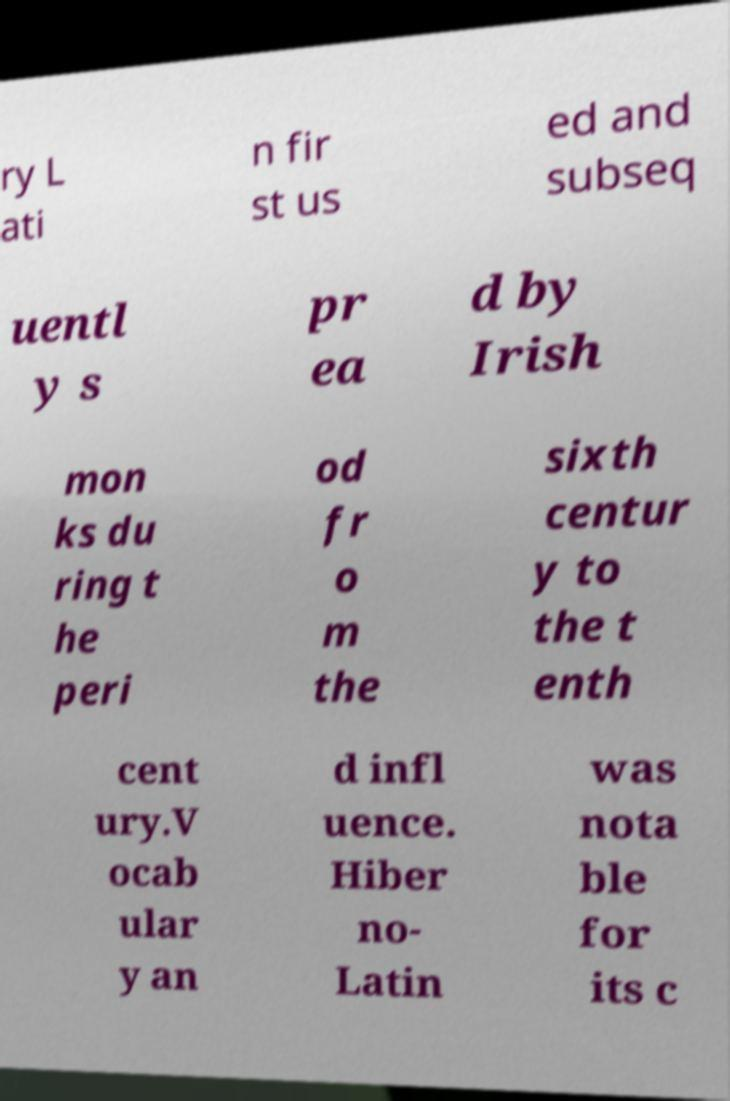What messages or text are displayed in this image? I need them in a readable, typed format. ry L ati n fir st us ed and subseq uentl y s pr ea d by Irish mon ks du ring t he peri od fr o m the sixth centur y to the t enth cent ury.V ocab ular y an d infl uence. Hiber no- Latin was nota ble for its c 